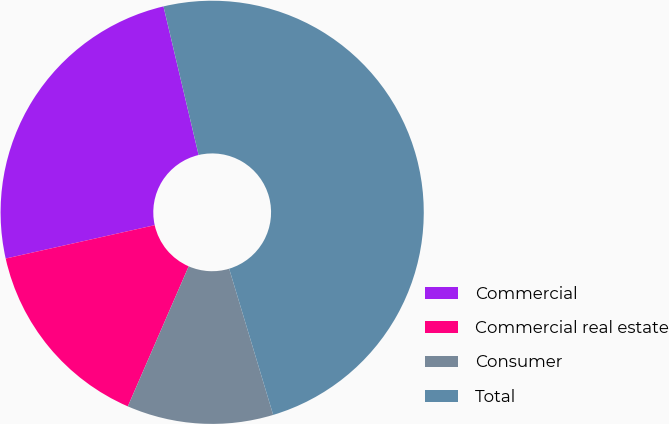<chart> <loc_0><loc_0><loc_500><loc_500><pie_chart><fcel>Commercial<fcel>Commercial real estate<fcel>Consumer<fcel>Total<nl><fcel>24.81%<fcel>14.97%<fcel>11.18%<fcel>49.04%<nl></chart> 